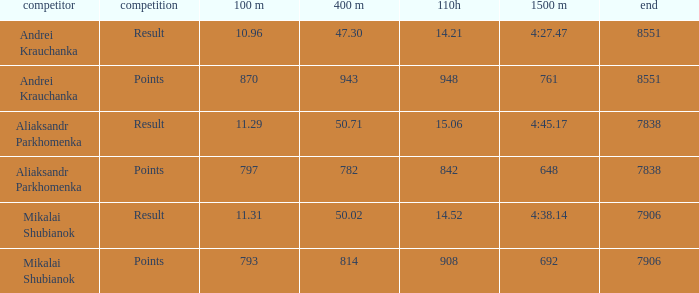What was the 400m that had a 110H greater than 14.21, a final of more than 7838, and having result in events? 1.0. 